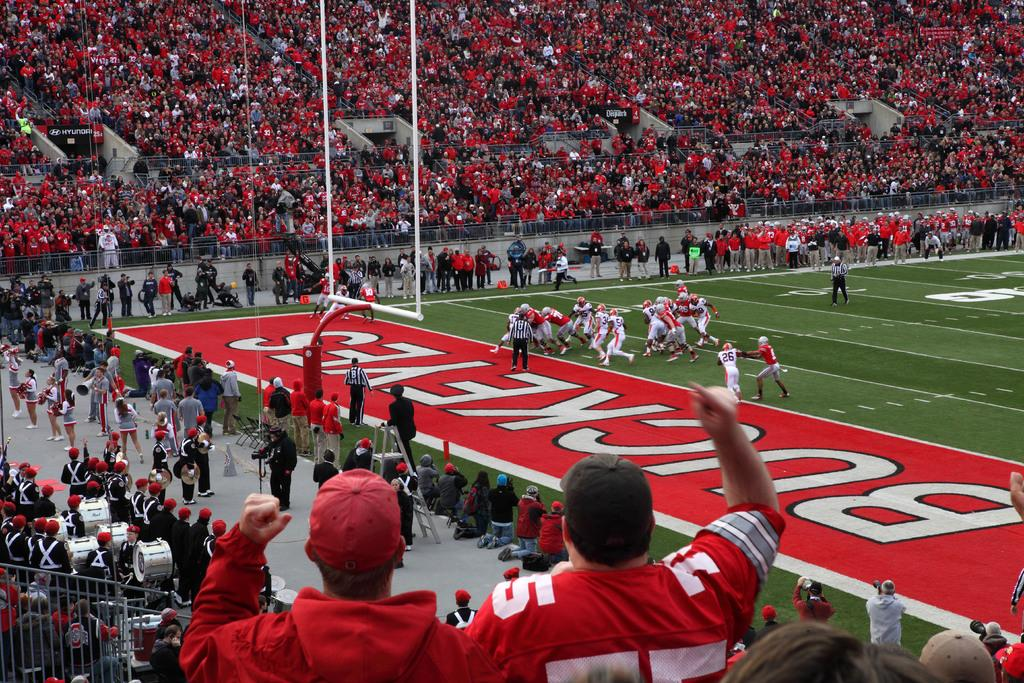<image>
Give a short and clear explanation of the subsequent image. a packed football stadium with the words Buckeyes on the field 